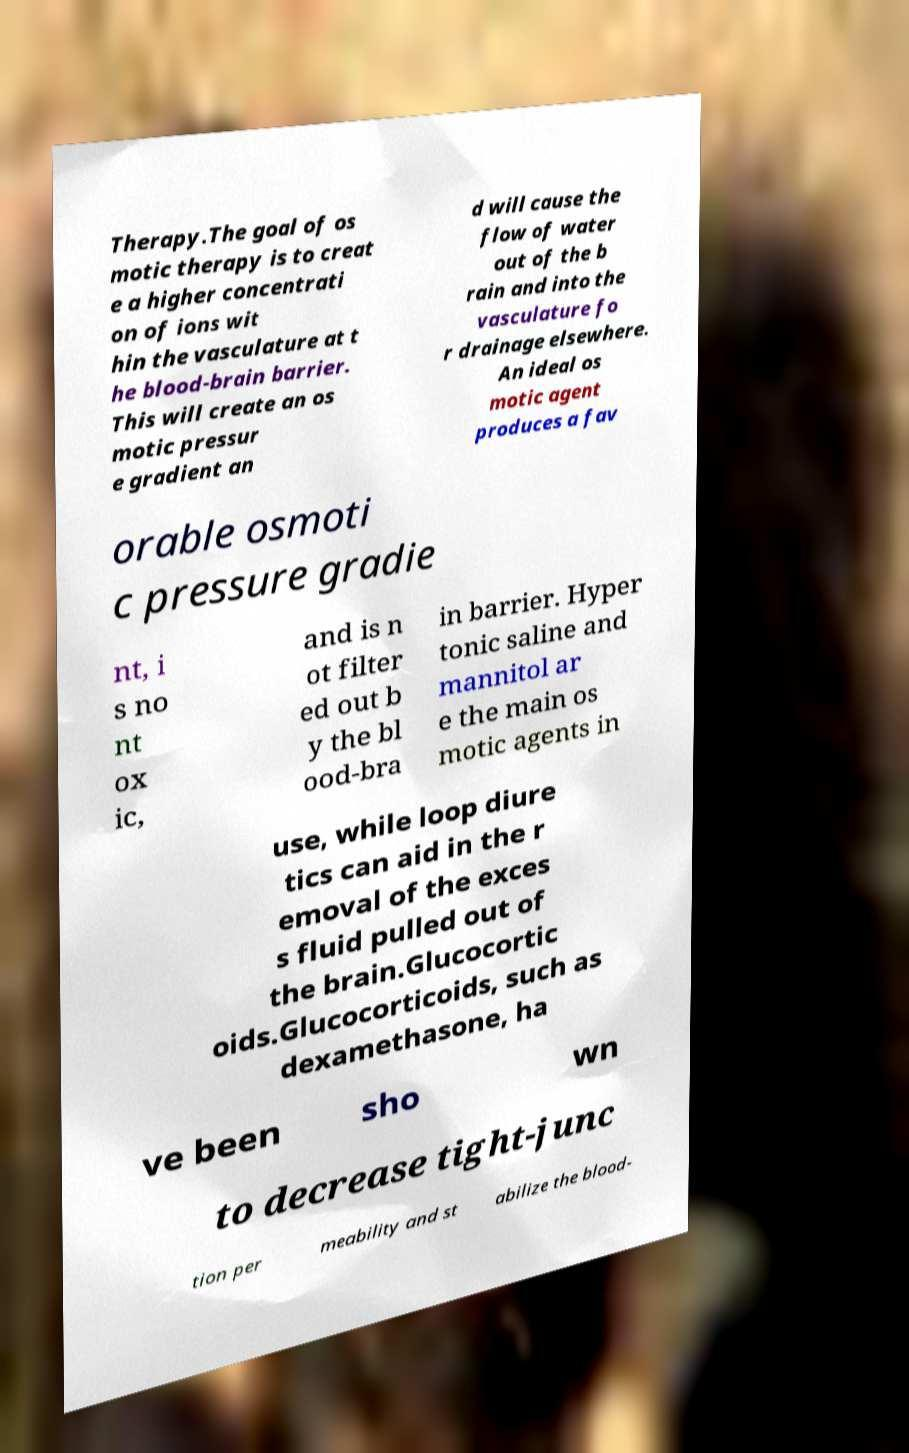Can you accurately transcribe the text from the provided image for me? Therapy.The goal of os motic therapy is to creat e a higher concentrati on of ions wit hin the vasculature at t he blood-brain barrier. This will create an os motic pressur e gradient an d will cause the flow of water out of the b rain and into the vasculature fo r drainage elsewhere. An ideal os motic agent produces a fav orable osmoti c pressure gradie nt, i s no nt ox ic, and is n ot filter ed out b y the bl ood-bra in barrier. Hyper tonic saline and mannitol ar e the main os motic agents in use, while loop diure tics can aid in the r emoval of the exces s fluid pulled out of the brain.Glucocortic oids.Glucocorticoids, such as dexamethasone, ha ve been sho wn to decrease tight-junc tion per meability and st abilize the blood- 